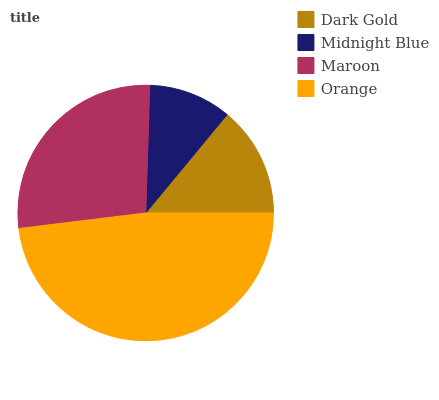Is Midnight Blue the minimum?
Answer yes or no. Yes. Is Orange the maximum?
Answer yes or no. Yes. Is Maroon the minimum?
Answer yes or no. No. Is Maroon the maximum?
Answer yes or no. No. Is Maroon greater than Midnight Blue?
Answer yes or no. Yes. Is Midnight Blue less than Maroon?
Answer yes or no. Yes. Is Midnight Blue greater than Maroon?
Answer yes or no. No. Is Maroon less than Midnight Blue?
Answer yes or no. No. Is Maroon the high median?
Answer yes or no. Yes. Is Dark Gold the low median?
Answer yes or no. Yes. Is Midnight Blue the high median?
Answer yes or no. No. Is Maroon the low median?
Answer yes or no. No. 